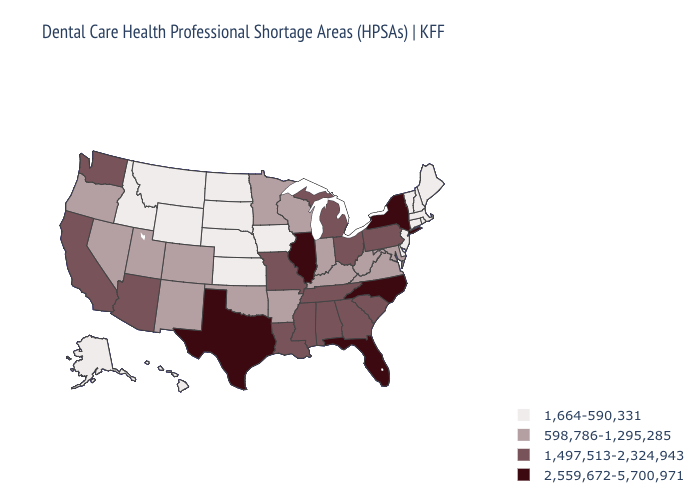What is the value of Oregon?
Answer briefly. 598,786-1,295,285. What is the lowest value in the West?
Be succinct. 1,664-590,331. Does Pennsylvania have the lowest value in the Northeast?
Short answer required. No. What is the highest value in states that border Illinois?
Quick response, please. 1,497,513-2,324,943. Name the states that have a value in the range 2,559,672-5,700,971?
Write a very short answer. Florida, Illinois, New York, North Carolina, Texas. Name the states that have a value in the range 1,497,513-2,324,943?
Concise answer only. Alabama, Arizona, California, Georgia, Louisiana, Michigan, Mississippi, Missouri, Ohio, Pennsylvania, South Carolina, Tennessee, Washington. Does Texas have the highest value in the South?
Give a very brief answer. Yes. Name the states that have a value in the range 598,786-1,295,285?
Give a very brief answer. Arkansas, Colorado, Indiana, Kentucky, Maryland, Minnesota, Nevada, New Mexico, Oklahoma, Oregon, Utah, Virginia, West Virginia, Wisconsin. Name the states that have a value in the range 1,664-590,331?
Be succinct. Alaska, Connecticut, Delaware, Hawaii, Idaho, Iowa, Kansas, Maine, Massachusetts, Montana, Nebraska, New Hampshire, New Jersey, North Dakota, Rhode Island, South Dakota, Vermont, Wyoming. Does the first symbol in the legend represent the smallest category?
Concise answer only. Yes. Name the states that have a value in the range 1,497,513-2,324,943?
Quick response, please. Alabama, Arizona, California, Georgia, Louisiana, Michigan, Mississippi, Missouri, Ohio, Pennsylvania, South Carolina, Tennessee, Washington. Does Michigan have a higher value than Texas?
Give a very brief answer. No. Which states hav the highest value in the Northeast?
Short answer required. New York. Name the states that have a value in the range 598,786-1,295,285?
Write a very short answer. Arkansas, Colorado, Indiana, Kentucky, Maryland, Minnesota, Nevada, New Mexico, Oklahoma, Oregon, Utah, Virginia, West Virginia, Wisconsin. Name the states that have a value in the range 2,559,672-5,700,971?
Concise answer only. Florida, Illinois, New York, North Carolina, Texas. 